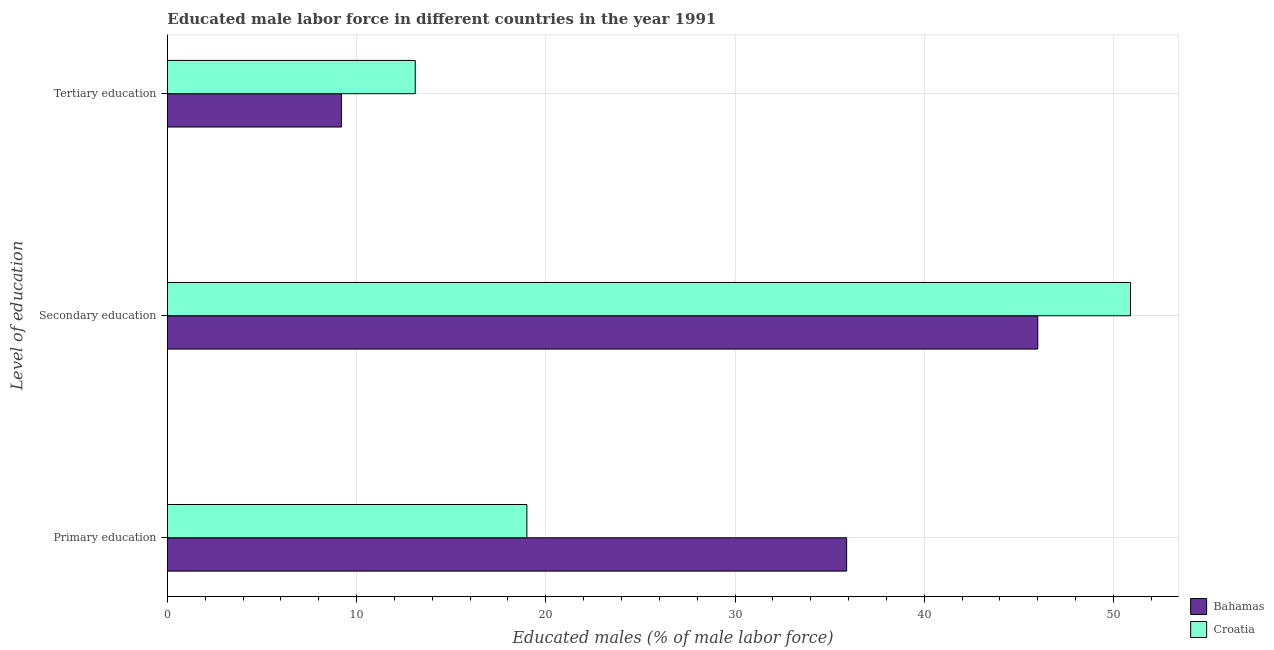Are the number of bars per tick equal to the number of legend labels?
Provide a succinct answer. Yes. How many bars are there on the 1st tick from the bottom?
Your answer should be compact. 2. What is the label of the 1st group of bars from the top?
Your answer should be very brief. Tertiary education. What is the percentage of male labor force who received tertiary education in Croatia?
Give a very brief answer. 13.1. Across all countries, what is the maximum percentage of male labor force who received primary education?
Make the answer very short. 35.9. Across all countries, what is the minimum percentage of male labor force who received primary education?
Ensure brevity in your answer.  19. In which country was the percentage of male labor force who received secondary education maximum?
Your answer should be compact. Croatia. In which country was the percentage of male labor force who received secondary education minimum?
Keep it short and to the point. Bahamas. What is the total percentage of male labor force who received tertiary education in the graph?
Your answer should be very brief. 22.3. What is the difference between the percentage of male labor force who received primary education in Bahamas and that in Croatia?
Provide a succinct answer. 16.9. What is the difference between the percentage of male labor force who received tertiary education in Bahamas and the percentage of male labor force who received primary education in Croatia?
Your response must be concise. -9.8. What is the average percentage of male labor force who received primary education per country?
Offer a terse response. 27.45. What is the difference between the percentage of male labor force who received tertiary education and percentage of male labor force who received secondary education in Croatia?
Keep it short and to the point. -37.8. What is the ratio of the percentage of male labor force who received tertiary education in Croatia to that in Bahamas?
Your answer should be compact. 1.42. Is the difference between the percentage of male labor force who received primary education in Croatia and Bahamas greater than the difference between the percentage of male labor force who received tertiary education in Croatia and Bahamas?
Offer a terse response. No. What is the difference between the highest and the second highest percentage of male labor force who received primary education?
Keep it short and to the point. 16.9. What is the difference between the highest and the lowest percentage of male labor force who received tertiary education?
Offer a very short reply. 3.9. In how many countries, is the percentage of male labor force who received primary education greater than the average percentage of male labor force who received primary education taken over all countries?
Your answer should be very brief. 1. Is the sum of the percentage of male labor force who received primary education in Bahamas and Croatia greater than the maximum percentage of male labor force who received secondary education across all countries?
Your response must be concise. Yes. What does the 1st bar from the top in Tertiary education represents?
Provide a succinct answer. Croatia. What does the 1st bar from the bottom in Tertiary education represents?
Ensure brevity in your answer.  Bahamas. Are all the bars in the graph horizontal?
Provide a succinct answer. Yes. What is the difference between two consecutive major ticks on the X-axis?
Provide a short and direct response. 10. Does the graph contain any zero values?
Your answer should be very brief. No. Does the graph contain grids?
Keep it short and to the point. Yes. What is the title of the graph?
Give a very brief answer. Educated male labor force in different countries in the year 1991. What is the label or title of the X-axis?
Your response must be concise. Educated males (% of male labor force). What is the label or title of the Y-axis?
Ensure brevity in your answer.  Level of education. What is the Educated males (% of male labor force) of Bahamas in Primary education?
Offer a terse response. 35.9. What is the Educated males (% of male labor force) in Croatia in Secondary education?
Give a very brief answer. 50.9. What is the Educated males (% of male labor force) of Bahamas in Tertiary education?
Offer a very short reply. 9.2. What is the Educated males (% of male labor force) of Croatia in Tertiary education?
Your response must be concise. 13.1. Across all Level of education, what is the maximum Educated males (% of male labor force) in Bahamas?
Ensure brevity in your answer.  46. Across all Level of education, what is the maximum Educated males (% of male labor force) of Croatia?
Offer a very short reply. 50.9. Across all Level of education, what is the minimum Educated males (% of male labor force) of Bahamas?
Ensure brevity in your answer.  9.2. Across all Level of education, what is the minimum Educated males (% of male labor force) in Croatia?
Make the answer very short. 13.1. What is the total Educated males (% of male labor force) of Bahamas in the graph?
Your answer should be compact. 91.1. What is the difference between the Educated males (% of male labor force) in Croatia in Primary education and that in Secondary education?
Provide a succinct answer. -31.9. What is the difference between the Educated males (% of male labor force) of Bahamas in Primary education and that in Tertiary education?
Your answer should be compact. 26.7. What is the difference between the Educated males (% of male labor force) of Croatia in Primary education and that in Tertiary education?
Your response must be concise. 5.9. What is the difference between the Educated males (% of male labor force) of Bahamas in Secondary education and that in Tertiary education?
Provide a succinct answer. 36.8. What is the difference between the Educated males (% of male labor force) of Croatia in Secondary education and that in Tertiary education?
Make the answer very short. 37.8. What is the difference between the Educated males (% of male labor force) of Bahamas in Primary education and the Educated males (% of male labor force) of Croatia in Secondary education?
Your response must be concise. -15. What is the difference between the Educated males (% of male labor force) in Bahamas in Primary education and the Educated males (% of male labor force) in Croatia in Tertiary education?
Keep it short and to the point. 22.8. What is the difference between the Educated males (% of male labor force) in Bahamas in Secondary education and the Educated males (% of male labor force) in Croatia in Tertiary education?
Ensure brevity in your answer.  32.9. What is the average Educated males (% of male labor force) of Bahamas per Level of education?
Offer a terse response. 30.37. What is the average Educated males (% of male labor force) of Croatia per Level of education?
Your answer should be compact. 27.67. What is the difference between the Educated males (% of male labor force) of Bahamas and Educated males (% of male labor force) of Croatia in Secondary education?
Offer a terse response. -4.9. What is the ratio of the Educated males (% of male labor force) of Bahamas in Primary education to that in Secondary education?
Keep it short and to the point. 0.78. What is the ratio of the Educated males (% of male labor force) in Croatia in Primary education to that in Secondary education?
Ensure brevity in your answer.  0.37. What is the ratio of the Educated males (% of male labor force) of Bahamas in Primary education to that in Tertiary education?
Your response must be concise. 3.9. What is the ratio of the Educated males (% of male labor force) of Croatia in Primary education to that in Tertiary education?
Your response must be concise. 1.45. What is the ratio of the Educated males (% of male labor force) of Croatia in Secondary education to that in Tertiary education?
Offer a very short reply. 3.89. What is the difference between the highest and the second highest Educated males (% of male labor force) in Bahamas?
Offer a very short reply. 10.1. What is the difference between the highest and the second highest Educated males (% of male labor force) in Croatia?
Offer a very short reply. 31.9. What is the difference between the highest and the lowest Educated males (% of male labor force) of Bahamas?
Ensure brevity in your answer.  36.8. What is the difference between the highest and the lowest Educated males (% of male labor force) in Croatia?
Offer a terse response. 37.8. 